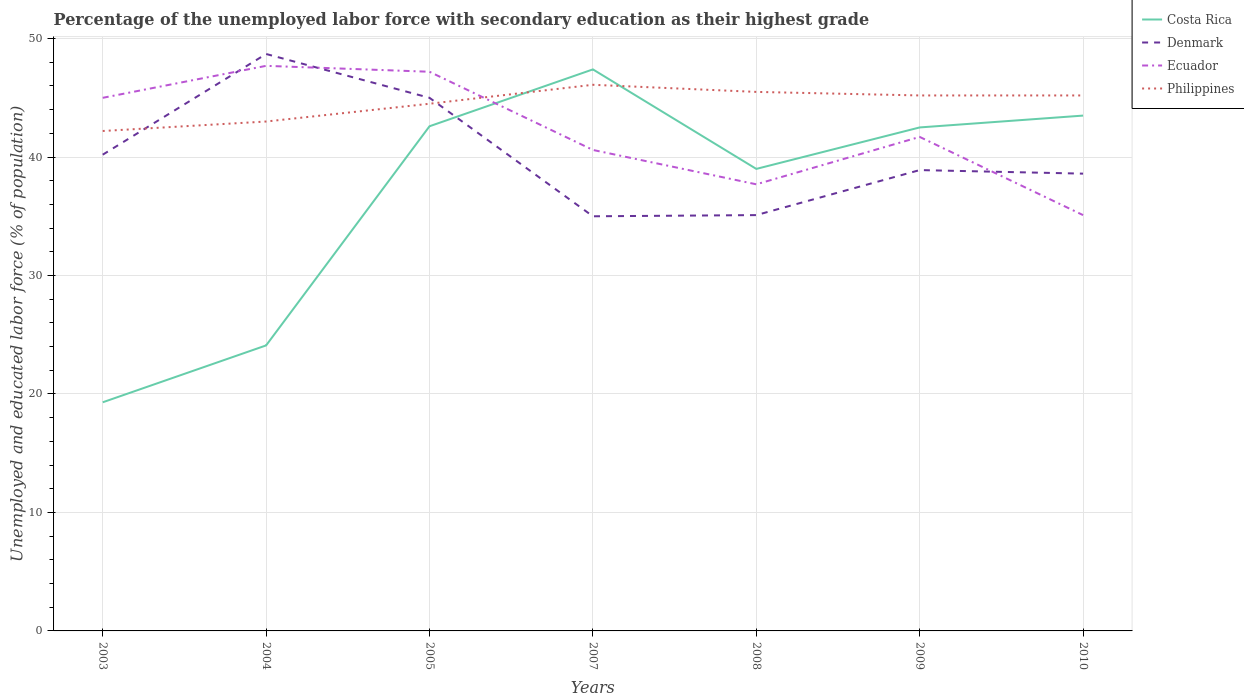Is the number of lines equal to the number of legend labels?
Give a very brief answer. Yes. Across all years, what is the maximum percentage of the unemployed labor force with secondary education in Philippines?
Make the answer very short. 42.2. In which year was the percentage of the unemployed labor force with secondary education in Ecuador maximum?
Make the answer very short. 2010. What is the difference between the highest and the second highest percentage of the unemployed labor force with secondary education in Denmark?
Make the answer very short. 13.7. Is the percentage of the unemployed labor force with secondary education in Ecuador strictly greater than the percentage of the unemployed labor force with secondary education in Philippines over the years?
Offer a terse response. No. How many lines are there?
Offer a terse response. 4. How many years are there in the graph?
Your answer should be compact. 7. Where does the legend appear in the graph?
Your answer should be compact. Top right. How many legend labels are there?
Offer a terse response. 4. What is the title of the graph?
Give a very brief answer. Percentage of the unemployed labor force with secondary education as their highest grade. What is the label or title of the Y-axis?
Offer a terse response. Unemployed and educated labor force (% of population). What is the Unemployed and educated labor force (% of population) of Costa Rica in 2003?
Your response must be concise. 19.3. What is the Unemployed and educated labor force (% of population) in Denmark in 2003?
Ensure brevity in your answer.  40.2. What is the Unemployed and educated labor force (% of population) in Ecuador in 2003?
Your answer should be compact. 45. What is the Unemployed and educated labor force (% of population) of Philippines in 2003?
Offer a terse response. 42.2. What is the Unemployed and educated labor force (% of population) in Costa Rica in 2004?
Provide a short and direct response. 24.1. What is the Unemployed and educated labor force (% of population) of Denmark in 2004?
Offer a terse response. 48.7. What is the Unemployed and educated labor force (% of population) in Ecuador in 2004?
Offer a terse response. 47.7. What is the Unemployed and educated labor force (% of population) in Costa Rica in 2005?
Provide a short and direct response. 42.6. What is the Unemployed and educated labor force (% of population) of Denmark in 2005?
Offer a very short reply. 45. What is the Unemployed and educated labor force (% of population) of Ecuador in 2005?
Your answer should be very brief. 47.2. What is the Unemployed and educated labor force (% of population) in Philippines in 2005?
Your answer should be compact. 44.5. What is the Unemployed and educated labor force (% of population) in Costa Rica in 2007?
Your answer should be very brief. 47.4. What is the Unemployed and educated labor force (% of population) in Denmark in 2007?
Provide a short and direct response. 35. What is the Unemployed and educated labor force (% of population) in Ecuador in 2007?
Keep it short and to the point. 40.6. What is the Unemployed and educated labor force (% of population) of Philippines in 2007?
Provide a short and direct response. 46.1. What is the Unemployed and educated labor force (% of population) of Denmark in 2008?
Ensure brevity in your answer.  35.1. What is the Unemployed and educated labor force (% of population) in Ecuador in 2008?
Make the answer very short. 37.7. What is the Unemployed and educated labor force (% of population) in Philippines in 2008?
Your response must be concise. 45.5. What is the Unemployed and educated labor force (% of population) of Costa Rica in 2009?
Your answer should be compact. 42.5. What is the Unemployed and educated labor force (% of population) of Denmark in 2009?
Ensure brevity in your answer.  38.9. What is the Unemployed and educated labor force (% of population) of Ecuador in 2009?
Ensure brevity in your answer.  41.7. What is the Unemployed and educated labor force (% of population) in Philippines in 2009?
Ensure brevity in your answer.  45.2. What is the Unemployed and educated labor force (% of population) of Costa Rica in 2010?
Offer a very short reply. 43.5. What is the Unemployed and educated labor force (% of population) of Denmark in 2010?
Offer a very short reply. 38.6. What is the Unemployed and educated labor force (% of population) in Ecuador in 2010?
Your answer should be compact. 35.1. What is the Unemployed and educated labor force (% of population) in Philippines in 2010?
Offer a very short reply. 45.2. Across all years, what is the maximum Unemployed and educated labor force (% of population) of Costa Rica?
Offer a terse response. 47.4. Across all years, what is the maximum Unemployed and educated labor force (% of population) of Denmark?
Keep it short and to the point. 48.7. Across all years, what is the maximum Unemployed and educated labor force (% of population) of Ecuador?
Your response must be concise. 47.7. Across all years, what is the maximum Unemployed and educated labor force (% of population) of Philippines?
Make the answer very short. 46.1. Across all years, what is the minimum Unemployed and educated labor force (% of population) of Costa Rica?
Give a very brief answer. 19.3. Across all years, what is the minimum Unemployed and educated labor force (% of population) of Ecuador?
Your answer should be very brief. 35.1. Across all years, what is the minimum Unemployed and educated labor force (% of population) in Philippines?
Keep it short and to the point. 42.2. What is the total Unemployed and educated labor force (% of population) of Costa Rica in the graph?
Your answer should be compact. 258.4. What is the total Unemployed and educated labor force (% of population) of Denmark in the graph?
Your response must be concise. 281.5. What is the total Unemployed and educated labor force (% of population) of Ecuador in the graph?
Make the answer very short. 295. What is the total Unemployed and educated labor force (% of population) of Philippines in the graph?
Offer a terse response. 311.7. What is the difference between the Unemployed and educated labor force (% of population) of Costa Rica in 2003 and that in 2004?
Make the answer very short. -4.8. What is the difference between the Unemployed and educated labor force (% of population) of Denmark in 2003 and that in 2004?
Offer a terse response. -8.5. What is the difference between the Unemployed and educated labor force (% of population) in Costa Rica in 2003 and that in 2005?
Your answer should be compact. -23.3. What is the difference between the Unemployed and educated labor force (% of population) in Denmark in 2003 and that in 2005?
Give a very brief answer. -4.8. What is the difference between the Unemployed and educated labor force (% of population) in Ecuador in 2003 and that in 2005?
Keep it short and to the point. -2.2. What is the difference between the Unemployed and educated labor force (% of population) of Costa Rica in 2003 and that in 2007?
Your answer should be compact. -28.1. What is the difference between the Unemployed and educated labor force (% of population) in Ecuador in 2003 and that in 2007?
Your response must be concise. 4.4. What is the difference between the Unemployed and educated labor force (% of population) in Philippines in 2003 and that in 2007?
Your answer should be very brief. -3.9. What is the difference between the Unemployed and educated labor force (% of population) in Costa Rica in 2003 and that in 2008?
Your response must be concise. -19.7. What is the difference between the Unemployed and educated labor force (% of population) of Denmark in 2003 and that in 2008?
Make the answer very short. 5.1. What is the difference between the Unemployed and educated labor force (% of population) in Philippines in 2003 and that in 2008?
Make the answer very short. -3.3. What is the difference between the Unemployed and educated labor force (% of population) in Costa Rica in 2003 and that in 2009?
Your response must be concise. -23.2. What is the difference between the Unemployed and educated labor force (% of population) of Denmark in 2003 and that in 2009?
Provide a short and direct response. 1.3. What is the difference between the Unemployed and educated labor force (% of population) of Ecuador in 2003 and that in 2009?
Give a very brief answer. 3.3. What is the difference between the Unemployed and educated labor force (% of population) in Philippines in 2003 and that in 2009?
Offer a terse response. -3. What is the difference between the Unemployed and educated labor force (% of population) in Costa Rica in 2003 and that in 2010?
Give a very brief answer. -24.2. What is the difference between the Unemployed and educated labor force (% of population) of Denmark in 2003 and that in 2010?
Your answer should be compact. 1.6. What is the difference between the Unemployed and educated labor force (% of population) of Ecuador in 2003 and that in 2010?
Keep it short and to the point. 9.9. What is the difference between the Unemployed and educated labor force (% of population) in Costa Rica in 2004 and that in 2005?
Make the answer very short. -18.5. What is the difference between the Unemployed and educated labor force (% of population) in Ecuador in 2004 and that in 2005?
Ensure brevity in your answer.  0.5. What is the difference between the Unemployed and educated labor force (% of population) of Costa Rica in 2004 and that in 2007?
Offer a terse response. -23.3. What is the difference between the Unemployed and educated labor force (% of population) of Denmark in 2004 and that in 2007?
Your answer should be very brief. 13.7. What is the difference between the Unemployed and educated labor force (% of population) of Philippines in 2004 and that in 2007?
Offer a very short reply. -3.1. What is the difference between the Unemployed and educated labor force (% of population) in Costa Rica in 2004 and that in 2008?
Keep it short and to the point. -14.9. What is the difference between the Unemployed and educated labor force (% of population) of Denmark in 2004 and that in 2008?
Offer a very short reply. 13.6. What is the difference between the Unemployed and educated labor force (% of population) of Philippines in 2004 and that in 2008?
Offer a very short reply. -2.5. What is the difference between the Unemployed and educated labor force (% of population) in Costa Rica in 2004 and that in 2009?
Make the answer very short. -18.4. What is the difference between the Unemployed and educated labor force (% of population) in Denmark in 2004 and that in 2009?
Provide a succinct answer. 9.8. What is the difference between the Unemployed and educated labor force (% of population) in Ecuador in 2004 and that in 2009?
Offer a very short reply. 6. What is the difference between the Unemployed and educated labor force (% of population) of Costa Rica in 2004 and that in 2010?
Your answer should be very brief. -19.4. What is the difference between the Unemployed and educated labor force (% of population) in Denmark in 2004 and that in 2010?
Your answer should be compact. 10.1. What is the difference between the Unemployed and educated labor force (% of population) of Ecuador in 2005 and that in 2007?
Your answer should be compact. 6.6. What is the difference between the Unemployed and educated labor force (% of population) of Philippines in 2005 and that in 2007?
Provide a short and direct response. -1.6. What is the difference between the Unemployed and educated labor force (% of population) in Costa Rica in 2005 and that in 2008?
Your answer should be very brief. 3.6. What is the difference between the Unemployed and educated labor force (% of population) of Ecuador in 2005 and that in 2008?
Keep it short and to the point. 9.5. What is the difference between the Unemployed and educated labor force (% of population) in Philippines in 2005 and that in 2008?
Make the answer very short. -1. What is the difference between the Unemployed and educated labor force (% of population) in Costa Rica in 2005 and that in 2009?
Keep it short and to the point. 0.1. What is the difference between the Unemployed and educated labor force (% of population) of Denmark in 2005 and that in 2009?
Give a very brief answer. 6.1. What is the difference between the Unemployed and educated labor force (% of population) in Ecuador in 2005 and that in 2009?
Ensure brevity in your answer.  5.5. What is the difference between the Unemployed and educated labor force (% of population) in Philippines in 2005 and that in 2009?
Provide a succinct answer. -0.7. What is the difference between the Unemployed and educated labor force (% of population) in Denmark in 2005 and that in 2010?
Your response must be concise. 6.4. What is the difference between the Unemployed and educated labor force (% of population) of Ecuador in 2007 and that in 2008?
Provide a succinct answer. 2.9. What is the difference between the Unemployed and educated labor force (% of population) of Philippines in 2007 and that in 2008?
Offer a very short reply. 0.6. What is the difference between the Unemployed and educated labor force (% of population) of Denmark in 2007 and that in 2009?
Your answer should be very brief. -3.9. What is the difference between the Unemployed and educated labor force (% of population) in Philippines in 2007 and that in 2009?
Your answer should be compact. 0.9. What is the difference between the Unemployed and educated labor force (% of population) of Costa Rica in 2008 and that in 2009?
Give a very brief answer. -3.5. What is the difference between the Unemployed and educated labor force (% of population) of Ecuador in 2008 and that in 2009?
Make the answer very short. -4. What is the difference between the Unemployed and educated labor force (% of population) of Costa Rica in 2008 and that in 2010?
Your answer should be very brief. -4.5. What is the difference between the Unemployed and educated labor force (% of population) in Denmark in 2008 and that in 2010?
Offer a very short reply. -3.5. What is the difference between the Unemployed and educated labor force (% of population) of Costa Rica in 2009 and that in 2010?
Offer a terse response. -1. What is the difference between the Unemployed and educated labor force (% of population) in Philippines in 2009 and that in 2010?
Ensure brevity in your answer.  0. What is the difference between the Unemployed and educated labor force (% of population) in Costa Rica in 2003 and the Unemployed and educated labor force (% of population) in Denmark in 2004?
Make the answer very short. -29.4. What is the difference between the Unemployed and educated labor force (% of population) in Costa Rica in 2003 and the Unemployed and educated labor force (% of population) in Ecuador in 2004?
Offer a terse response. -28.4. What is the difference between the Unemployed and educated labor force (% of population) of Costa Rica in 2003 and the Unemployed and educated labor force (% of population) of Philippines in 2004?
Offer a terse response. -23.7. What is the difference between the Unemployed and educated labor force (% of population) of Ecuador in 2003 and the Unemployed and educated labor force (% of population) of Philippines in 2004?
Keep it short and to the point. 2. What is the difference between the Unemployed and educated labor force (% of population) in Costa Rica in 2003 and the Unemployed and educated labor force (% of population) in Denmark in 2005?
Your answer should be compact. -25.7. What is the difference between the Unemployed and educated labor force (% of population) in Costa Rica in 2003 and the Unemployed and educated labor force (% of population) in Ecuador in 2005?
Give a very brief answer. -27.9. What is the difference between the Unemployed and educated labor force (% of population) of Costa Rica in 2003 and the Unemployed and educated labor force (% of population) of Philippines in 2005?
Your answer should be compact. -25.2. What is the difference between the Unemployed and educated labor force (% of population) in Costa Rica in 2003 and the Unemployed and educated labor force (% of population) in Denmark in 2007?
Offer a terse response. -15.7. What is the difference between the Unemployed and educated labor force (% of population) in Costa Rica in 2003 and the Unemployed and educated labor force (% of population) in Ecuador in 2007?
Provide a succinct answer. -21.3. What is the difference between the Unemployed and educated labor force (% of population) in Costa Rica in 2003 and the Unemployed and educated labor force (% of population) in Philippines in 2007?
Keep it short and to the point. -26.8. What is the difference between the Unemployed and educated labor force (% of population) of Ecuador in 2003 and the Unemployed and educated labor force (% of population) of Philippines in 2007?
Your response must be concise. -1.1. What is the difference between the Unemployed and educated labor force (% of population) in Costa Rica in 2003 and the Unemployed and educated labor force (% of population) in Denmark in 2008?
Provide a succinct answer. -15.8. What is the difference between the Unemployed and educated labor force (% of population) in Costa Rica in 2003 and the Unemployed and educated labor force (% of population) in Ecuador in 2008?
Ensure brevity in your answer.  -18.4. What is the difference between the Unemployed and educated labor force (% of population) of Costa Rica in 2003 and the Unemployed and educated labor force (% of population) of Philippines in 2008?
Offer a terse response. -26.2. What is the difference between the Unemployed and educated labor force (% of population) of Denmark in 2003 and the Unemployed and educated labor force (% of population) of Ecuador in 2008?
Ensure brevity in your answer.  2.5. What is the difference between the Unemployed and educated labor force (% of population) of Ecuador in 2003 and the Unemployed and educated labor force (% of population) of Philippines in 2008?
Offer a very short reply. -0.5. What is the difference between the Unemployed and educated labor force (% of population) in Costa Rica in 2003 and the Unemployed and educated labor force (% of population) in Denmark in 2009?
Your response must be concise. -19.6. What is the difference between the Unemployed and educated labor force (% of population) of Costa Rica in 2003 and the Unemployed and educated labor force (% of population) of Ecuador in 2009?
Make the answer very short. -22.4. What is the difference between the Unemployed and educated labor force (% of population) of Costa Rica in 2003 and the Unemployed and educated labor force (% of population) of Philippines in 2009?
Offer a very short reply. -25.9. What is the difference between the Unemployed and educated labor force (% of population) in Denmark in 2003 and the Unemployed and educated labor force (% of population) in Ecuador in 2009?
Ensure brevity in your answer.  -1.5. What is the difference between the Unemployed and educated labor force (% of population) of Denmark in 2003 and the Unemployed and educated labor force (% of population) of Philippines in 2009?
Make the answer very short. -5. What is the difference between the Unemployed and educated labor force (% of population) of Ecuador in 2003 and the Unemployed and educated labor force (% of population) of Philippines in 2009?
Offer a very short reply. -0.2. What is the difference between the Unemployed and educated labor force (% of population) in Costa Rica in 2003 and the Unemployed and educated labor force (% of population) in Denmark in 2010?
Give a very brief answer. -19.3. What is the difference between the Unemployed and educated labor force (% of population) in Costa Rica in 2003 and the Unemployed and educated labor force (% of population) in Ecuador in 2010?
Give a very brief answer. -15.8. What is the difference between the Unemployed and educated labor force (% of population) in Costa Rica in 2003 and the Unemployed and educated labor force (% of population) in Philippines in 2010?
Your answer should be compact. -25.9. What is the difference between the Unemployed and educated labor force (% of population) of Denmark in 2003 and the Unemployed and educated labor force (% of population) of Philippines in 2010?
Ensure brevity in your answer.  -5. What is the difference between the Unemployed and educated labor force (% of population) of Ecuador in 2003 and the Unemployed and educated labor force (% of population) of Philippines in 2010?
Your response must be concise. -0.2. What is the difference between the Unemployed and educated labor force (% of population) in Costa Rica in 2004 and the Unemployed and educated labor force (% of population) in Denmark in 2005?
Provide a succinct answer. -20.9. What is the difference between the Unemployed and educated labor force (% of population) of Costa Rica in 2004 and the Unemployed and educated labor force (% of population) of Ecuador in 2005?
Provide a short and direct response. -23.1. What is the difference between the Unemployed and educated labor force (% of population) in Costa Rica in 2004 and the Unemployed and educated labor force (% of population) in Philippines in 2005?
Provide a short and direct response. -20.4. What is the difference between the Unemployed and educated labor force (% of population) of Denmark in 2004 and the Unemployed and educated labor force (% of population) of Ecuador in 2005?
Provide a short and direct response. 1.5. What is the difference between the Unemployed and educated labor force (% of population) in Denmark in 2004 and the Unemployed and educated labor force (% of population) in Philippines in 2005?
Provide a short and direct response. 4.2. What is the difference between the Unemployed and educated labor force (% of population) of Costa Rica in 2004 and the Unemployed and educated labor force (% of population) of Denmark in 2007?
Give a very brief answer. -10.9. What is the difference between the Unemployed and educated labor force (% of population) of Costa Rica in 2004 and the Unemployed and educated labor force (% of population) of Ecuador in 2007?
Make the answer very short. -16.5. What is the difference between the Unemployed and educated labor force (% of population) of Costa Rica in 2004 and the Unemployed and educated labor force (% of population) of Philippines in 2007?
Keep it short and to the point. -22. What is the difference between the Unemployed and educated labor force (% of population) in Costa Rica in 2004 and the Unemployed and educated labor force (% of population) in Philippines in 2008?
Your response must be concise. -21.4. What is the difference between the Unemployed and educated labor force (% of population) in Ecuador in 2004 and the Unemployed and educated labor force (% of population) in Philippines in 2008?
Make the answer very short. 2.2. What is the difference between the Unemployed and educated labor force (% of population) of Costa Rica in 2004 and the Unemployed and educated labor force (% of population) of Denmark in 2009?
Make the answer very short. -14.8. What is the difference between the Unemployed and educated labor force (% of population) in Costa Rica in 2004 and the Unemployed and educated labor force (% of population) in Ecuador in 2009?
Ensure brevity in your answer.  -17.6. What is the difference between the Unemployed and educated labor force (% of population) in Costa Rica in 2004 and the Unemployed and educated labor force (% of population) in Philippines in 2009?
Provide a short and direct response. -21.1. What is the difference between the Unemployed and educated labor force (% of population) in Ecuador in 2004 and the Unemployed and educated labor force (% of population) in Philippines in 2009?
Provide a short and direct response. 2.5. What is the difference between the Unemployed and educated labor force (% of population) in Costa Rica in 2004 and the Unemployed and educated labor force (% of population) in Denmark in 2010?
Your answer should be very brief. -14.5. What is the difference between the Unemployed and educated labor force (% of population) of Costa Rica in 2004 and the Unemployed and educated labor force (% of population) of Ecuador in 2010?
Give a very brief answer. -11. What is the difference between the Unemployed and educated labor force (% of population) in Costa Rica in 2004 and the Unemployed and educated labor force (% of population) in Philippines in 2010?
Ensure brevity in your answer.  -21.1. What is the difference between the Unemployed and educated labor force (% of population) in Denmark in 2004 and the Unemployed and educated labor force (% of population) in Ecuador in 2010?
Give a very brief answer. 13.6. What is the difference between the Unemployed and educated labor force (% of population) of Costa Rica in 2005 and the Unemployed and educated labor force (% of population) of Ecuador in 2007?
Your answer should be compact. 2. What is the difference between the Unemployed and educated labor force (% of population) of Ecuador in 2005 and the Unemployed and educated labor force (% of population) of Philippines in 2007?
Ensure brevity in your answer.  1.1. What is the difference between the Unemployed and educated labor force (% of population) in Costa Rica in 2005 and the Unemployed and educated labor force (% of population) in Denmark in 2008?
Offer a very short reply. 7.5. What is the difference between the Unemployed and educated labor force (% of population) in Costa Rica in 2005 and the Unemployed and educated labor force (% of population) in Ecuador in 2008?
Your response must be concise. 4.9. What is the difference between the Unemployed and educated labor force (% of population) of Costa Rica in 2005 and the Unemployed and educated labor force (% of population) of Philippines in 2008?
Give a very brief answer. -2.9. What is the difference between the Unemployed and educated labor force (% of population) in Denmark in 2005 and the Unemployed and educated labor force (% of population) in Ecuador in 2008?
Give a very brief answer. 7.3. What is the difference between the Unemployed and educated labor force (% of population) of Ecuador in 2005 and the Unemployed and educated labor force (% of population) of Philippines in 2008?
Your answer should be very brief. 1.7. What is the difference between the Unemployed and educated labor force (% of population) of Costa Rica in 2005 and the Unemployed and educated labor force (% of population) of Denmark in 2009?
Provide a short and direct response. 3.7. What is the difference between the Unemployed and educated labor force (% of population) in Costa Rica in 2005 and the Unemployed and educated labor force (% of population) in Ecuador in 2009?
Your answer should be compact. 0.9. What is the difference between the Unemployed and educated labor force (% of population) in Costa Rica in 2005 and the Unemployed and educated labor force (% of population) in Philippines in 2009?
Offer a very short reply. -2.6. What is the difference between the Unemployed and educated labor force (% of population) of Ecuador in 2005 and the Unemployed and educated labor force (% of population) of Philippines in 2009?
Give a very brief answer. 2. What is the difference between the Unemployed and educated labor force (% of population) in Costa Rica in 2005 and the Unemployed and educated labor force (% of population) in Philippines in 2010?
Keep it short and to the point. -2.6. What is the difference between the Unemployed and educated labor force (% of population) of Costa Rica in 2007 and the Unemployed and educated labor force (% of population) of Denmark in 2008?
Provide a succinct answer. 12.3. What is the difference between the Unemployed and educated labor force (% of population) in Costa Rica in 2007 and the Unemployed and educated labor force (% of population) in Ecuador in 2008?
Keep it short and to the point. 9.7. What is the difference between the Unemployed and educated labor force (% of population) of Costa Rica in 2007 and the Unemployed and educated labor force (% of population) of Philippines in 2008?
Give a very brief answer. 1.9. What is the difference between the Unemployed and educated labor force (% of population) of Denmark in 2007 and the Unemployed and educated labor force (% of population) of Philippines in 2008?
Keep it short and to the point. -10.5. What is the difference between the Unemployed and educated labor force (% of population) of Ecuador in 2007 and the Unemployed and educated labor force (% of population) of Philippines in 2008?
Ensure brevity in your answer.  -4.9. What is the difference between the Unemployed and educated labor force (% of population) of Costa Rica in 2007 and the Unemployed and educated labor force (% of population) of Denmark in 2009?
Make the answer very short. 8.5. What is the difference between the Unemployed and educated labor force (% of population) in Ecuador in 2007 and the Unemployed and educated labor force (% of population) in Philippines in 2009?
Ensure brevity in your answer.  -4.6. What is the difference between the Unemployed and educated labor force (% of population) in Costa Rica in 2007 and the Unemployed and educated labor force (% of population) in Philippines in 2010?
Offer a terse response. 2.2. What is the difference between the Unemployed and educated labor force (% of population) in Denmark in 2007 and the Unemployed and educated labor force (% of population) in Ecuador in 2010?
Ensure brevity in your answer.  -0.1. What is the difference between the Unemployed and educated labor force (% of population) in Denmark in 2007 and the Unemployed and educated labor force (% of population) in Philippines in 2010?
Provide a succinct answer. -10.2. What is the difference between the Unemployed and educated labor force (% of population) of Ecuador in 2007 and the Unemployed and educated labor force (% of population) of Philippines in 2010?
Your response must be concise. -4.6. What is the difference between the Unemployed and educated labor force (% of population) in Costa Rica in 2008 and the Unemployed and educated labor force (% of population) in Ecuador in 2009?
Your response must be concise. -2.7. What is the difference between the Unemployed and educated labor force (% of population) in Denmark in 2008 and the Unemployed and educated labor force (% of population) in Ecuador in 2009?
Provide a succinct answer. -6.6. What is the difference between the Unemployed and educated labor force (% of population) of Ecuador in 2008 and the Unemployed and educated labor force (% of population) of Philippines in 2009?
Offer a terse response. -7.5. What is the difference between the Unemployed and educated labor force (% of population) of Costa Rica in 2008 and the Unemployed and educated labor force (% of population) of Denmark in 2010?
Offer a terse response. 0.4. What is the difference between the Unemployed and educated labor force (% of population) of Costa Rica in 2008 and the Unemployed and educated labor force (% of population) of Ecuador in 2010?
Ensure brevity in your answer.  3.9. What is the difference between the Unemployed and educated labor force (% of population) of Costa Rica in 2008 and the Unemployed and educated labor force (% of population) of Philippines in 2010?
Give a very brief answer. -6.2. What is the difference between the Unemployed and educated labor force (% of population) of Denmark in 2008 and the Unemployed and educated labor force (% of population) of Ecuador in 2010?
Provide a succinct answer. 0. What is the difference between the Unemployed and educated labor force (% of population) of Costa Rica in 2009 and the Unemployed and educated labor force (% of population) of Denmark in 2010?
Your response must be concise. 3.9. What is the difference between the Unemployed and educated labor force (% of population) of Costa Rica in 2009 and the Unemployed and educated labor force (% of population) of Ecuador in 2010?
Make the answer very short. 7.4. What is the average Unemployed and educated labor force (% of population) of Costa Rica per year?
Your answer should be very brief. 36.91. What is the average Unemployed and educated labor force (% of population) of Denmark per year?
Offer a very short reply. 40.21. What is the average Unemployed and educated labor force (% of population) in Ecuador per year?
Your answer should be compact. 42.14. What is the average Unemployed and educated labor force (% of population) of Philippines per year?
Keep it short and to the point. 44.53. In the year 2003, what is the difference between the Unemployed and educated labor force (% of population) in Costa Rica and Unemployed and educated labor force (% of population) in Denmark?
Make the answer very short. -20.9. In the year 2003, what is the difference between the Unemployed and educated labor force (% of population) in Costa Rica and Unemployed and educated labor force (% of population) in Ecuador?
Keep it short and to the point. -25.7. In the year 2003, what is the difference between the Unemployed and educated labor force (% of population) of Costa Rica and Unemployed and educated labor force (% of population) of Philippines?
Offer a very short reply. -22.9. In the year 2003, what is the difference between the Unemployed and educated labor force (% of population) in Denmark and Unemployed and educated labor force (% of population) in Ecuador?
Provide a short and direct response. -4.8. In the year 2003, what is the difference between the Unemployed and educated labor force (% of population) in Denmark and Unemployed and educated labor force (% of population) in Philippines?
Offer a terse response. -2. In the year 2004, what is the difference between the Unemployed and educated labor force (% of population) of Costa Rica and Unemployed and educated labor force (% of population) of Denmark?
Offer a terse response. -24.6. In the year 2004, what is the difference between the Unemployed and educated labor force (% of population) of Costa Rica and Unemployed and educated labor force (% of population) of Ecuador?
Your answer should be compact. -23.6. In the year 2004, what is the difference between the Unemployed and educated labor force (% of population) of Costa Rica and Unemployed and educated labor force (% of population) of Philippines?
Your response must be concise. -18.9. In the year 2005, what is the difference between the Unemployed and educated labor force (% of population) in Costa Rica and Unemployed and educated labor force (% of population) in Ecuador?
Give a very brief answer. -4.6. In the year 2005, what is the difference between the Unemployed and educated labor force (% of population) in Denmark and Unemployed and educated labor force (% of population) in Philippines?
Keep it short and to the point. 0.5. In the year 2005, what is the difference between the Unemployed and educated labor force (% of population) of Ecuador and Unemployed and educated labor force (% of population) of Philippines?
Keep it short and to the point. 2.7. In the year 2007, what is the difference between the Unemployed and educated labor force (% of population) of Costa Rica and Unemployed and educated labor force (% of population) of Denmark?
Ensure brevity in your answer.  12.4. In the year 2007, what is the difference between the Unemployed and educated labor force (% of population) of Costa Rica and Unemployed and educated labor force (% of population) of Philippines?
Offer a very short reply. 1.3. In the year 2007, what is the difference between the Unemployed and educated labor force (% of population) of Denmark and Unemployed and educated labor force (% of population) of Philippines?
Your answer should be very brief. -11.1. In the year 2008, what is the difference between the Unemployed and educated labor force (% of population) of Costa Rica and Unemployed and educated labor force (% of population) of Denmark?
Give a very brief answer. 3.9. In the year 2008, what is the difference between the Unemployed and educated labor force (% of population) in Costa Rica and Unemployed and educated labor force (% of population) in Ecuador?
Your answer should be very brief. 1.3. In the year 2008, what is the difference between the Unemployed and educated labor force (% of population) of Costa Rica and Unemployed and educated labor force (% of population) of Philippines?
Make the answer very short. -6.5. In the year 2008, what is the difference between the Unemployed and educated labor force (% of population) of Denmark and Unemployed and educated labor force (% of population) of Philippines?
Keep it short and to the point. -10.4. In the year 2010, what is the difference between the Unemployed and educated labor force (% of population) of Costa Rica and Unemployed and educated labor force (% of population) of Ecuador?
Your answer should be very brief. 8.4. In the year 2010, what is the difference between the Unemployed and educated labor force (% of population) in Denmark and Unemployed and educated labor force (% of population) in Philippines?
Make the answer very short. -6.6. What is the ratio of the Unemployed and educated labor force (% of population) of Costa Rica in 2003 to that in 2004?
Offer a terse response. 0.8. What is the ratio of the Unemployed and educated labor force (% of population) of Denmark in 2003 to that in 2004?
Make the answer very short. 0.83. What is the ratio of the Unemployed and educated labor force (% of population) of Ecuador in 2003 to that in 2004?
Offer a terse response. 0.94. What is the ratio of the Unemployed and educated labor force (% of population) in Philippines in 2003 to that in 2004?
Keep it short and to the point. 0.98. What is the ratio of the Unemployed and educated labor force (% of population) in Costa Rica in 2003 to that in 2005?
Ensure brevity in your answer.  0.45. What is the ratio of the Unemployed and educated labor force (% of population) in Denmark in 2003 to that in 2005?
Ensure brevity in your answer.  0.89. What is the ratio of the Unemployed and educated labor force (% of population) of Ecuador in 2003 to that in 2005?
Your response must be concise. 0.95. What is the ratio of the Unemployed and educated labor force (% of population) of Philippines in 2003 to that in 2005?
Provide a short and direct response. 0.95. What is the ratio of the Unemployed and educated labor force (% of population) in Costa Rica in 2003 to that in 2007?
Ensure brevity in your answer.  0.41. What is the ratio of the Unemployed and educated labor force (% of population) of Denmark in 2003 to that in 2007?
Offer a terse response. 1.15. What is the ratio of the Unemployed and educated labor force (% of population) of Ecuador in 2003 to that in 2007?
Keep it short and to the point. 1.11. What is the ratio of the Unemployed and educated labor force (% of population) of Philippines in 2003 to that in 2007?
Offer a terse response. 0.92. What is the ratio of the Unemployed and educated labor force (% of population) of Costa Rica in 2003 to that in 2008?
Offer a very short reply. 0.49. What is the ratio of the Unemployed and educated labor force (% of population) of Denmark in 2003 to that in 2008?
Make the answer very short. 1.15. What is the ratio of the Unemployed and educated labor force (% of population) in Ecuador in 2003 to that in 2008?
Give a very brief answer. 1.19. What is the ratio of the Unemployed and educated labor force (% of population) in Philippines in 2003 to that in 2008?
Your answer should be compact. 0.93. What is the ratio of the Unemployed and educated labor force (% of population) of Costa Rica in 2003 to that in 2009?
Make the answer very short. 0.45. What is the ratio of the Unemployed and educated labor force (% of population) in Denmark in 2003 to that in 2009?
Your answer should be compact. 1.03. What is the ratio of the Unemployed and educated labor force (% of population) of Ecuador in 2003 to that in 2009?
Your answer should be compact. 1.08. What is the ratio of the Unemployed and educated labor force (% of population) of Philippines in 2003 to that in 2009?
Offer a very short reply. 0.93. What is the ratio of the Unemployed and educated labor force (% of population) of Costa Rica in 2003 to that in 2010?
Offer a terse response. 0.44. What is the ratio of the Unemployed and educated labor force (% of population) in Denmark in 2003 to that in 2010?
Provide a succinct answer. 1.04. What is the ratio of the Unemployed and educated labor force (% of population) of Ecuador in 2003 to that in 2010?
Keep it short and to the point. 1.28. What is the ratio of the Unemployed and educated labor force (% of population) of Philippines in 2003 to that in 2010?
Offer a terse response. 0.93. What is the ratio of the Unemployed and educated labor force (% of population) of Costa Rica in 2004 to that in 2005?
Your answer should be very brief. 0.57. What is the ratio of the Unemployed and educated labor force (% of population) in Denmark in 2004 to that in 2005?
Offer a very short reply. 1.08. What is the ratio of the Unemployed and educated labor force (% of population) in Ecuador in 2004 to that in 2005?
Keep it short and to the point. 1.01. What is the ratio of the Unemployed and educated labor force (% of population) of Philippines in 2004 to that in 2005?
Give a very brief answer. 0.97. What is the ratio of the Unemployed and educated labor force (% of population) of Costa Rica in 2004 to that in 2007?
Keep it short and to the point. 0.51. What is the ratio of the Unemployed and educated labor force (% of population) of Denmark in 2004 to that in 2007?
Provide a short and direct response. 1.39. What is the ratio of the Unemployed and educated labor force (% of population) in Ecuador in 2004 to that in 2007?
Your answer should be compact. 1.17. What is the ratio of the Unemployed and educated labor force (% of population) of Philippines in 2004 to that in 2007?
Keep it short and to the point. 0.93. What is the ratio of the Unemployed and educated labor force (% of population) of Costa Rica in 2004 to that in 2008?
Your answer should be very brief. 0.62. What is the ratio of the Unemployed and educated labor force (% of population) of Denmark in 2004 to that in 2008?
Keep it short and to the point. 1.39. What is the ratio of the Unemployed and educated labor force (% of population) in Ecuador in 2004 to that in 2008?
Keep it short and to the point. 1.27. What is the ratio of the Unemployed and educated labor force (% of population) of Philippines in 2004 to that in 2008?
Your answer should be very brief. 0.95. What is the ratio of the Unemployed and educated labor force (% of population) in Costa Rica in 2004 to that in 2009?
Ensure brevity in your answer.  0.57. What is the ratio of the Unemployed and educated labor force (% of population) in Denmark in 2004 to that in 2009?
Your answer should be very brief. 1.25. What is the ratio of the Unemployed and educated labor force (% of population) in Ecuador in 2004 to that in 2009?
Offer a very short reply. 1.14. What is the ratio of the Unemployed and educated labor force (% of population) of Philippines in 2004 to that in 2009?
Provide a succinct answer. 0.95. What is the ratio of the Unemployed and educated labor force (% of population) in Costa Rica in 2004 to that in 2010?
Give a very brief answer. 0.55. What is the ratio of the Unemployed and educated labor force (% of population) in Denmark in 2004 to that in 2010?
Offer a terse response. 1.26. What is the ratio of the Unemployed and educated labor force (% of population) in Ecuador in 2004 to that in 2010?
Make the answer very short. 1.36. What is the ratio of the Unemployed and educated labor force (% of population) in Philippines in 2004 to that in 2010?
Provide a short and direct response. 0.95. What is the ratio of the Unemployed and educated labor force (% of population) of Costa Rica in 2005 to that in 2007?
Provide a succinct answer. 0.9. What is the ratio of the Unemployed and educated labor force (% of population) of Denmark in 2005 to that in 2007?
Give a very brief answer. 1.29. What is the ratio of the Unemployed and educated labor force (% of population) in Ecuador in 2005 to that in 2007?
Make the answer very short. 1.16. What is the ratio of the Unemployed and educated labor force (% of population) in Philippines in 2005 to that in 2007?
Provide a short and direct response. 0.97. What is the ratio of the Unemployed and educated labor force (% of population) of Costa Rica in 2005 to that in 2008?
Your answer should be very brief. 1.09. What is the ratio of the Unemployed and educated labor force (% of population) in Denmark in 2005 to that in 2008?
Give a very brief answer. 1.28. What is the ratio of the Unemployed and educated labor force (% of population) in Ecuador in 2005 to that in 2008?
Ensure brevity in your answer.  1.25. What is the ratio of the Unemployed and educated labor force (% of population) of Philippines in 2005 to that in 2008?
Give a very brief answer. 0.98. What is the ratio of the Unemployed and educated labor force (% of population) of Costa Rica in 2005 to that in 2009?
Your answer should be very brief. 1. What is the ratio of the Unemployed and educated labor force (% of population) of Denmark in 2005 to that in 2009?
Offer a very short reply. 1.16. What is the ratio of the Unemployed and educated labor force (% of population) in Ecuador in 2005 to that in 2009?
Your answer should be very brief. 1.13. What is the ratio of the Unemployed and educated labor force (% of population) in Philippines in 2005 to that in 2009?
Your answer should be compact. 0.98. What is the ratio of the Unemployed and educated labor force (% of population) in Costa Rica in 2005 to that in 2010?
Your answer should be compact. 0.98. What is the ratio of the Unemployed and educated labor force (% of population) of Denmark in 2005 to that in 2010?
Offer a very short reply. 1.17. What is the ratio of the Unemployed and educated labor force (% of population) of Ecuador in 2005 to that in 2010?
Ensure brevity in your answer.  1.34. What is the ratio of the Unemployed and educated labor force (% of population) in Philippines in 2005 to that in 2010?
Keep it short and to the point. 0.98. What is the ratio of the Unemployed and educated labor force (% of population) of Costa Rica in 2007 to that in 2008?
Your answer should be compact. 1.22. What is the ratio of the Unemployed and educated labor force (% of population) in Denmark in 2007 to that in 2008?
Give a very brief answer. 1. What is the ratio of the Unemployed and educated labor force (% of population) of Philippines in 2007 to that in 2008?
Provide a succinct answer. 1.01. What is the ratio of the Unemployed and educated labor force (% of population) of Costa Rica in 2007 to that in 2009?
Give a very brief answer. 1.12. What is the ratio of the Unemployed and educated labor force (% of population) of Denmark in 2007 to that in 2009?
Your response must be concise. 0.9. What is the ratio of the Unemployed and educated labor force (% of population) of Ecuador in 2007 to that in 2009?
Provide a short and direct response. 0.97. What is the ratio of the Unemployed and educated labor force (% of population) in Philippines in 2007 to that in 2009?
Give a very brief answer. 1.02. What is the ratio of the Unemployed and educated labor force (% of population) of Costa Rica in 2007 to that in 2010?
Your response must be concise. 1.09. What is the ratio of the Unemployed and educated labor force (% of population) of Denmark in 2007 to that in 2010?
Offer a terse response. 0.91. What is the ratio of the Unemployed and educated labor force (% of population) in Ecuador in 2007 to that in 2010?
Offer a very short reply. 1.16. What is the ratio of the Unemployed and educated labor force (% of population) of Philippines in 2007 to that in 2010?
Provide a short and direct response. 1.02. What is the ratio of the Unemployed and educated labor force (% of population) of Costa Rica in 2008 to that in 2009?
Offer a very short reply. 0.92. What is the ratio of the Unemployed and educated labor force (% of population) in Denmark in 2008 to that in 2009?
Make the answer very short. 0.9. What is the ratio of the Unemployed and educated labor force (% of population) of Ecuador in 2008 to that in 2009?
Give a very brief answer. 0.9. What is the ratio of the Unemployed and educated labor force (% of population) of Philippines in 2008 to that in 2009?
Offer a terse response. 1.01. What is the ratio of the Unemployed and educated labor force (% of population) of Costa Rica in 2008 to that in 2010?
Give a very brief answer. 0.9. What is the ratio of the Unemployed and educated labor force (% of population) of Denmark in 2008 to that in 2010?
Offer a very short reply. 0.91. What is the ratio of the Unemployed and educated labor force (% of population) of Ecuador in 2008 to that in 2010?
Provide a succinct answer. 1.07. What is the ratio of the Unemployed and educated labor force (% of population) in Philippines in 2008 to that in 2010?
Offer a terse response. 1.01. What is the ratio of the Unemployed and educated labor force (% of population) of Ecuador in 2009 to that in 2010?
Your response must be concise. 1.19. What is the difference between the highest and the second highest Unemployed and educated labor force (% of population) of Denmark?
Your response must be concise. 3.7. What is the difference between the highest and the lowest Unemployed and educated labor force (% of population) of Costa Rica?
Make the answer very short. 28.1. What is the difference between the highest and the lowest Unemployed and educated labor force (% of population) of Denmark?
Keep it short and to the point. 13.7. What is the difference between the highest and the lowest Unemployed and educated labor force (% of population) in Ecuador?
Your answer should be compact. 12.6. What is the difference between the highest and the lowest Unemployed and educated labor force (% of population) in Philippines?
Ensure brevity in your answer.  3.9. 